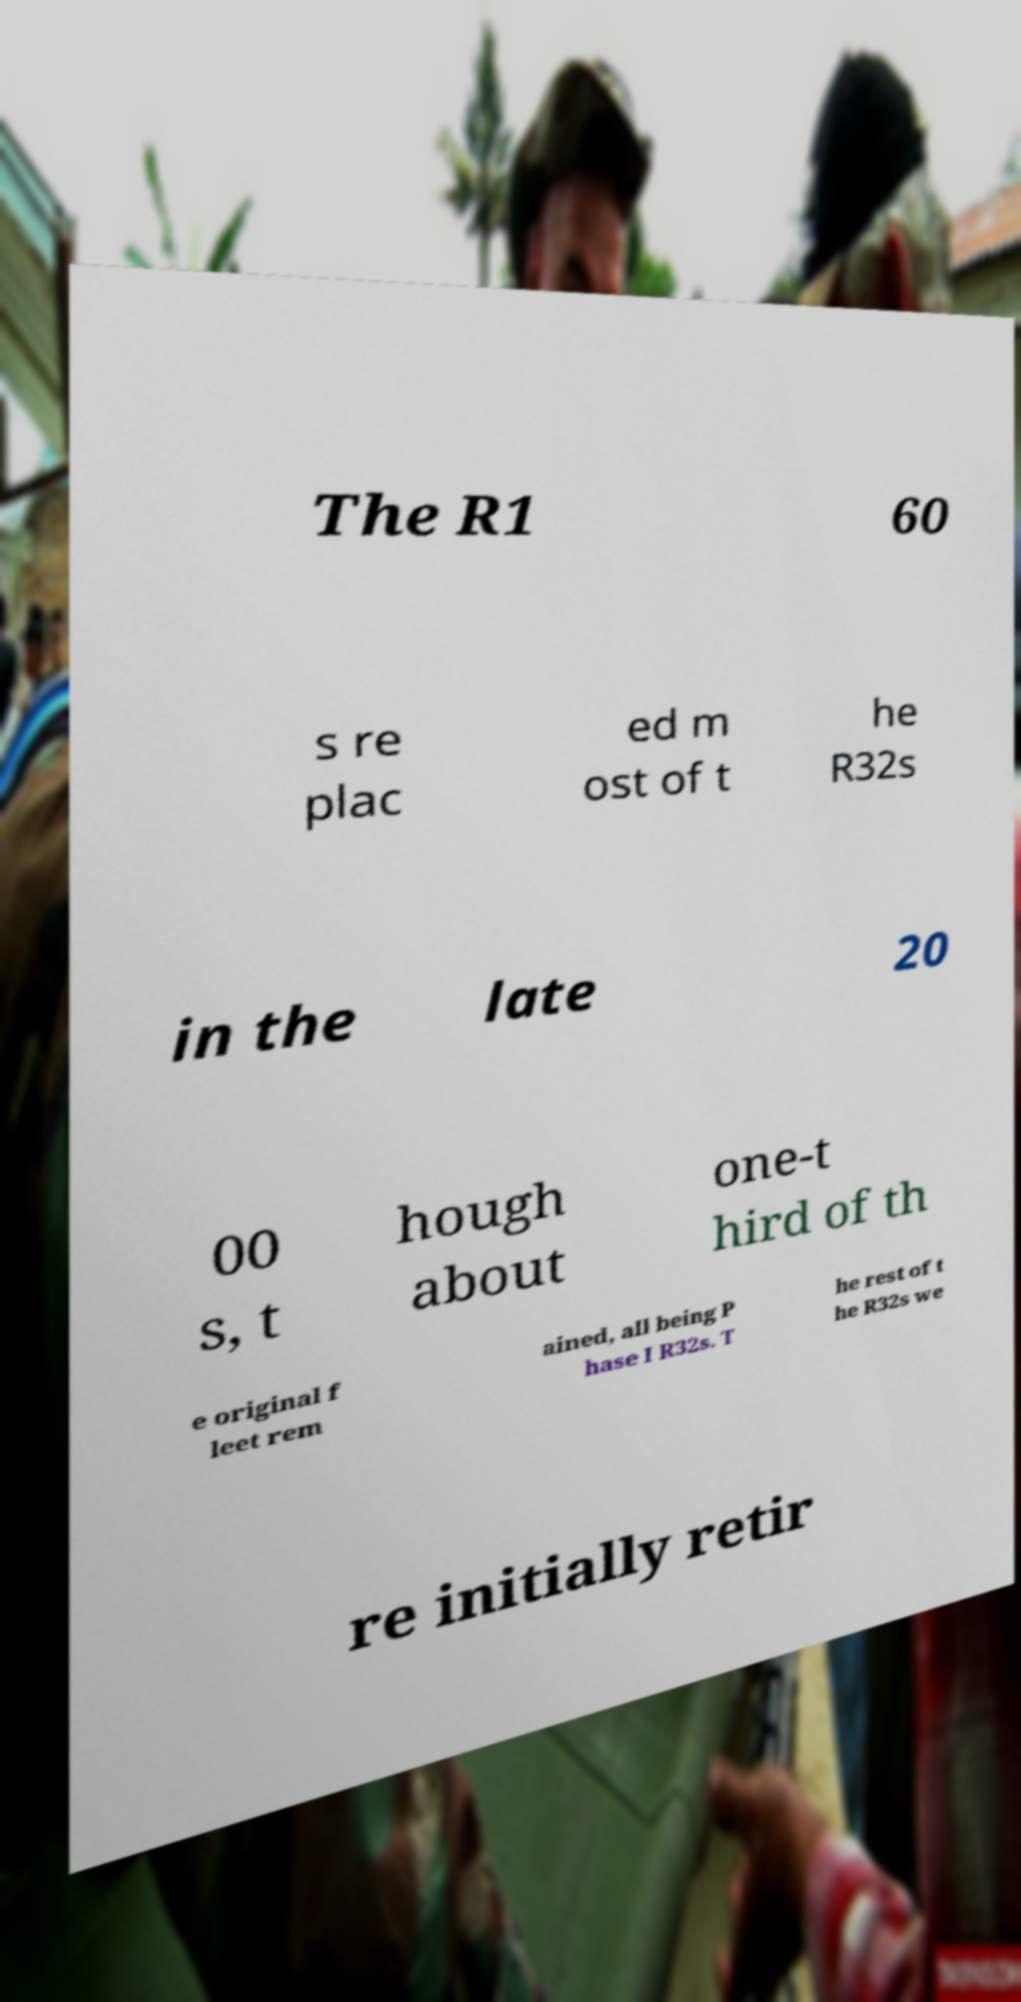What messages or text are displayed in this image? I need them in a readable, typed format. The R1 60 s re plac ed m ost of t he R32s in the late 20 00 s, t hough about one-t hird of th e original f leet rem ained, all being P hase I R32s. T he rest of t he R32s we re initially retir 